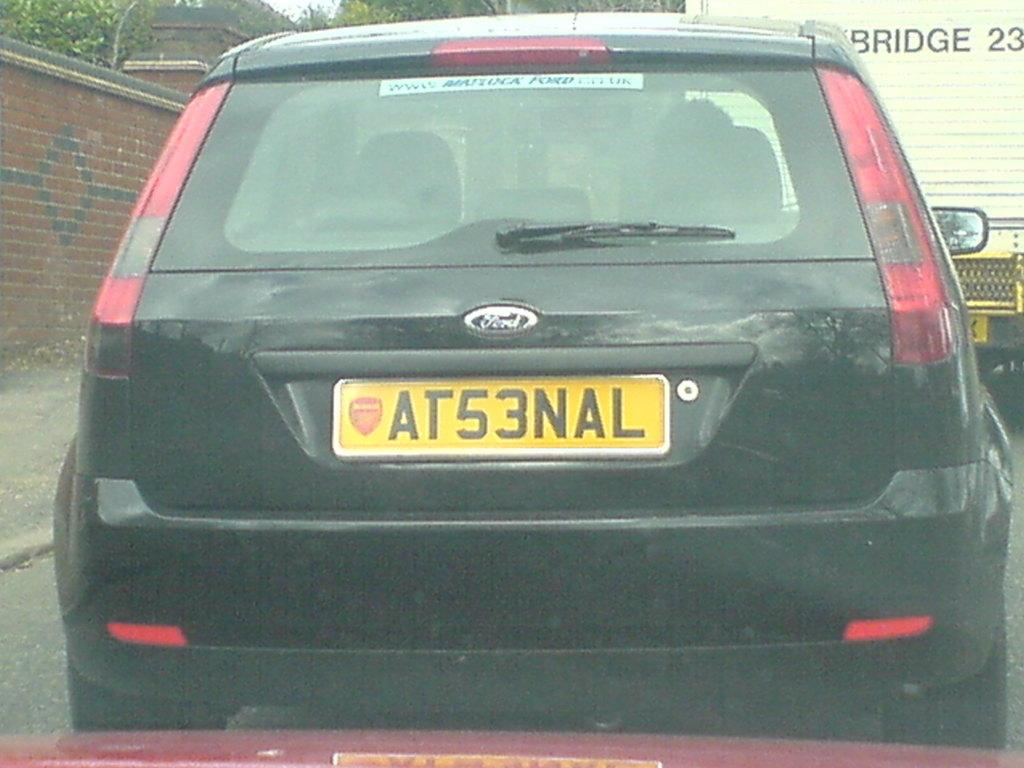<image>
Offer a succinct explanation of the picture presented. A black Ford car has the license plate AT53NAL. 